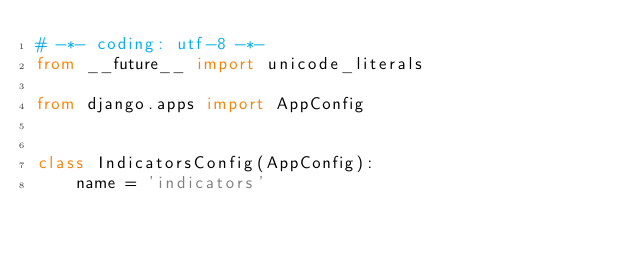Convert code to text. <code><loc_0><loc_0><loc_500><loc_500><_Python_># -*- coding: utf-8 -*-
from __future__ import unicode_literals

from django.apps import AppConfig


class IndicatorsConfig(AppConfig):
    name = 'indicators'
</code> 